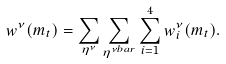Convert formula to latex. <formula><loc_0><loc_0><loc_500><loc_500>w ^ { \nu } ( m _ { t } ) = \sum _ { \eta ^ { \nu } } \sum _ { \eta ^ { \nu b a r } } \sum _ { i = 1 } ^ { 4 } w ^ { \nu } _ { i } ( m _ { t } ) .</formula> 